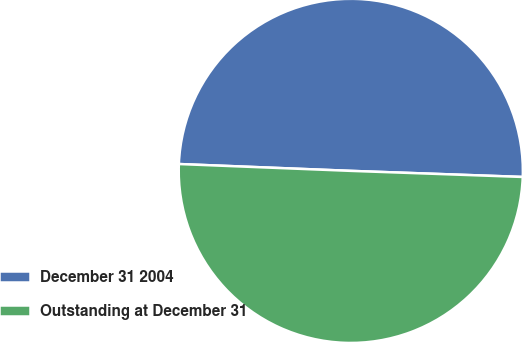Convert chart to OTSL. <chart><loc_0><loc_0><loc_500><loc_500><pie_chart><fcel>December 31 2004<fcel>Outstanding at December 31<nl><fcel>49.93%<fcel>50.07%<nl></chart> 